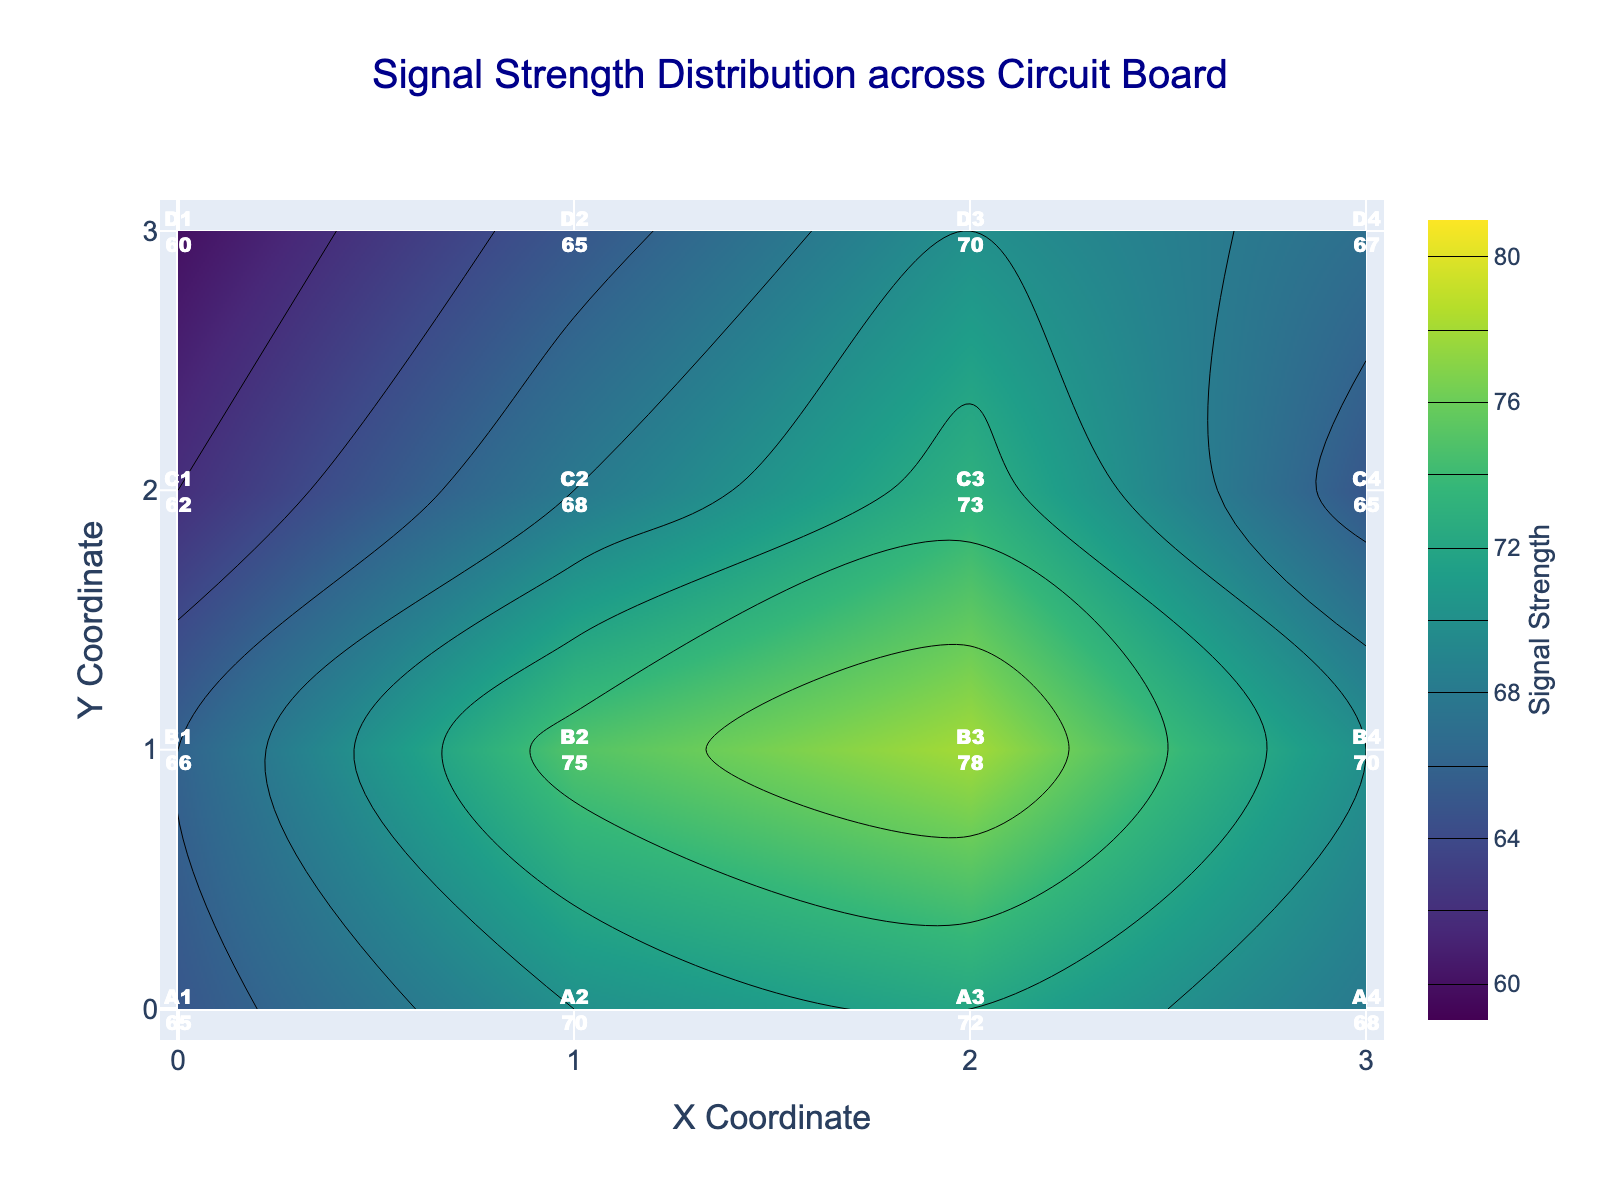Which region has the highest signal strength? The labels on the figure indicate the signal strength in each region. Observing the labels, region B3 has the highest value of 78.
Answer: B3 What's the overall range of signal strength values on the plot? The minimum signal strength in the plot is 60 (D1), and the maximum is 78 (B3). Therefore, the range is 78 - 60.
Answer: 18 How does the signal strength at region A3 compare to region C3? The figure shows the signal strength values for each region. A3 has a signal strength of 72, while C3 has 73.
Answer: C3 is higher What is the average signal strength of regions in row B? Sum the signal strengths of row B (66 + 75 + 78 + 70) and divide by the number of regions (4). (66 + 75 + 78 + 70) / 4 = 289 / 4 = 72.25
Answer: 72.25 Which row has the lowest average signal strength? Calculate the average signal strength for each row: 
Row A: (65+70+72+68)/4 = 68.75, 
Row B: (66+75+78+70)/4 = 72.25, 
Row C: (62+68+73+65)/4 = 67, 
Row D: (60+65+70+67)/4 = 65.5. 
Compare these average values, row D has the lowest average.
Answer: Row D What are the x and y coordinates of the region with the strongest signal strength? The figure shows that B3 has the highest signal strength of 78. Referring to the region labels, B3 corresponds to coordinates (2,1).
Answer: (2,1) What's the difference in signal strength between the maximum and minimum values in column 2? Find the signal strengths in column 2: 
Row D2: 65, Row C2: 68, Row B2: 75, Row A2: 70.
The maximum is 75 (B2) and the minimum is 65 (D2). The difference is 75 - 65.
Answer: 10 Which regions have a signal strength equal to 65? By checking the figure, the regions with a signal strength of 65 are D1, C4, and A1.
Answer: D1, C4, A1 In which quadrant (top-left, top-right, bottom-left, bottom-right) are the highest signal strengths mostly concentrated? Observing the highest values (above 70), they are mostly located in the top-right quadrant (A2, A3, B2, B3, B4).
Answer: Top-right 